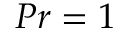<formula> <loc_0><loc_0><loc_500><loc_500>P r = 1</formula> 